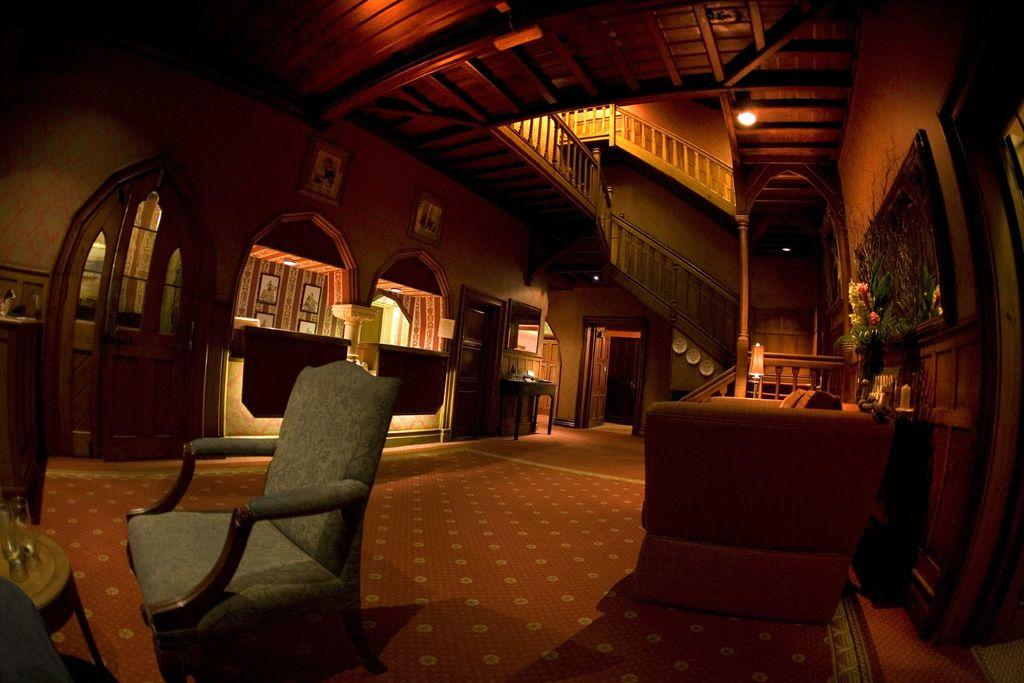What type of space is depicted in the image? The image is of a hall. What furniture is present in the hall? There is a sofa and a table in the hall. What decorative elements can be seen on the walls? There are frames on the walls. How can one access a higher level in the hall? There is a staircase in the hall. What type of decorative item is present on the table? There is a flower vase in the hall. What allows natural light to enter the hall? There are windows in the hall. What type of grass can be seen growing on the staircase in the image? There is no grass present on the staircase in the image. 